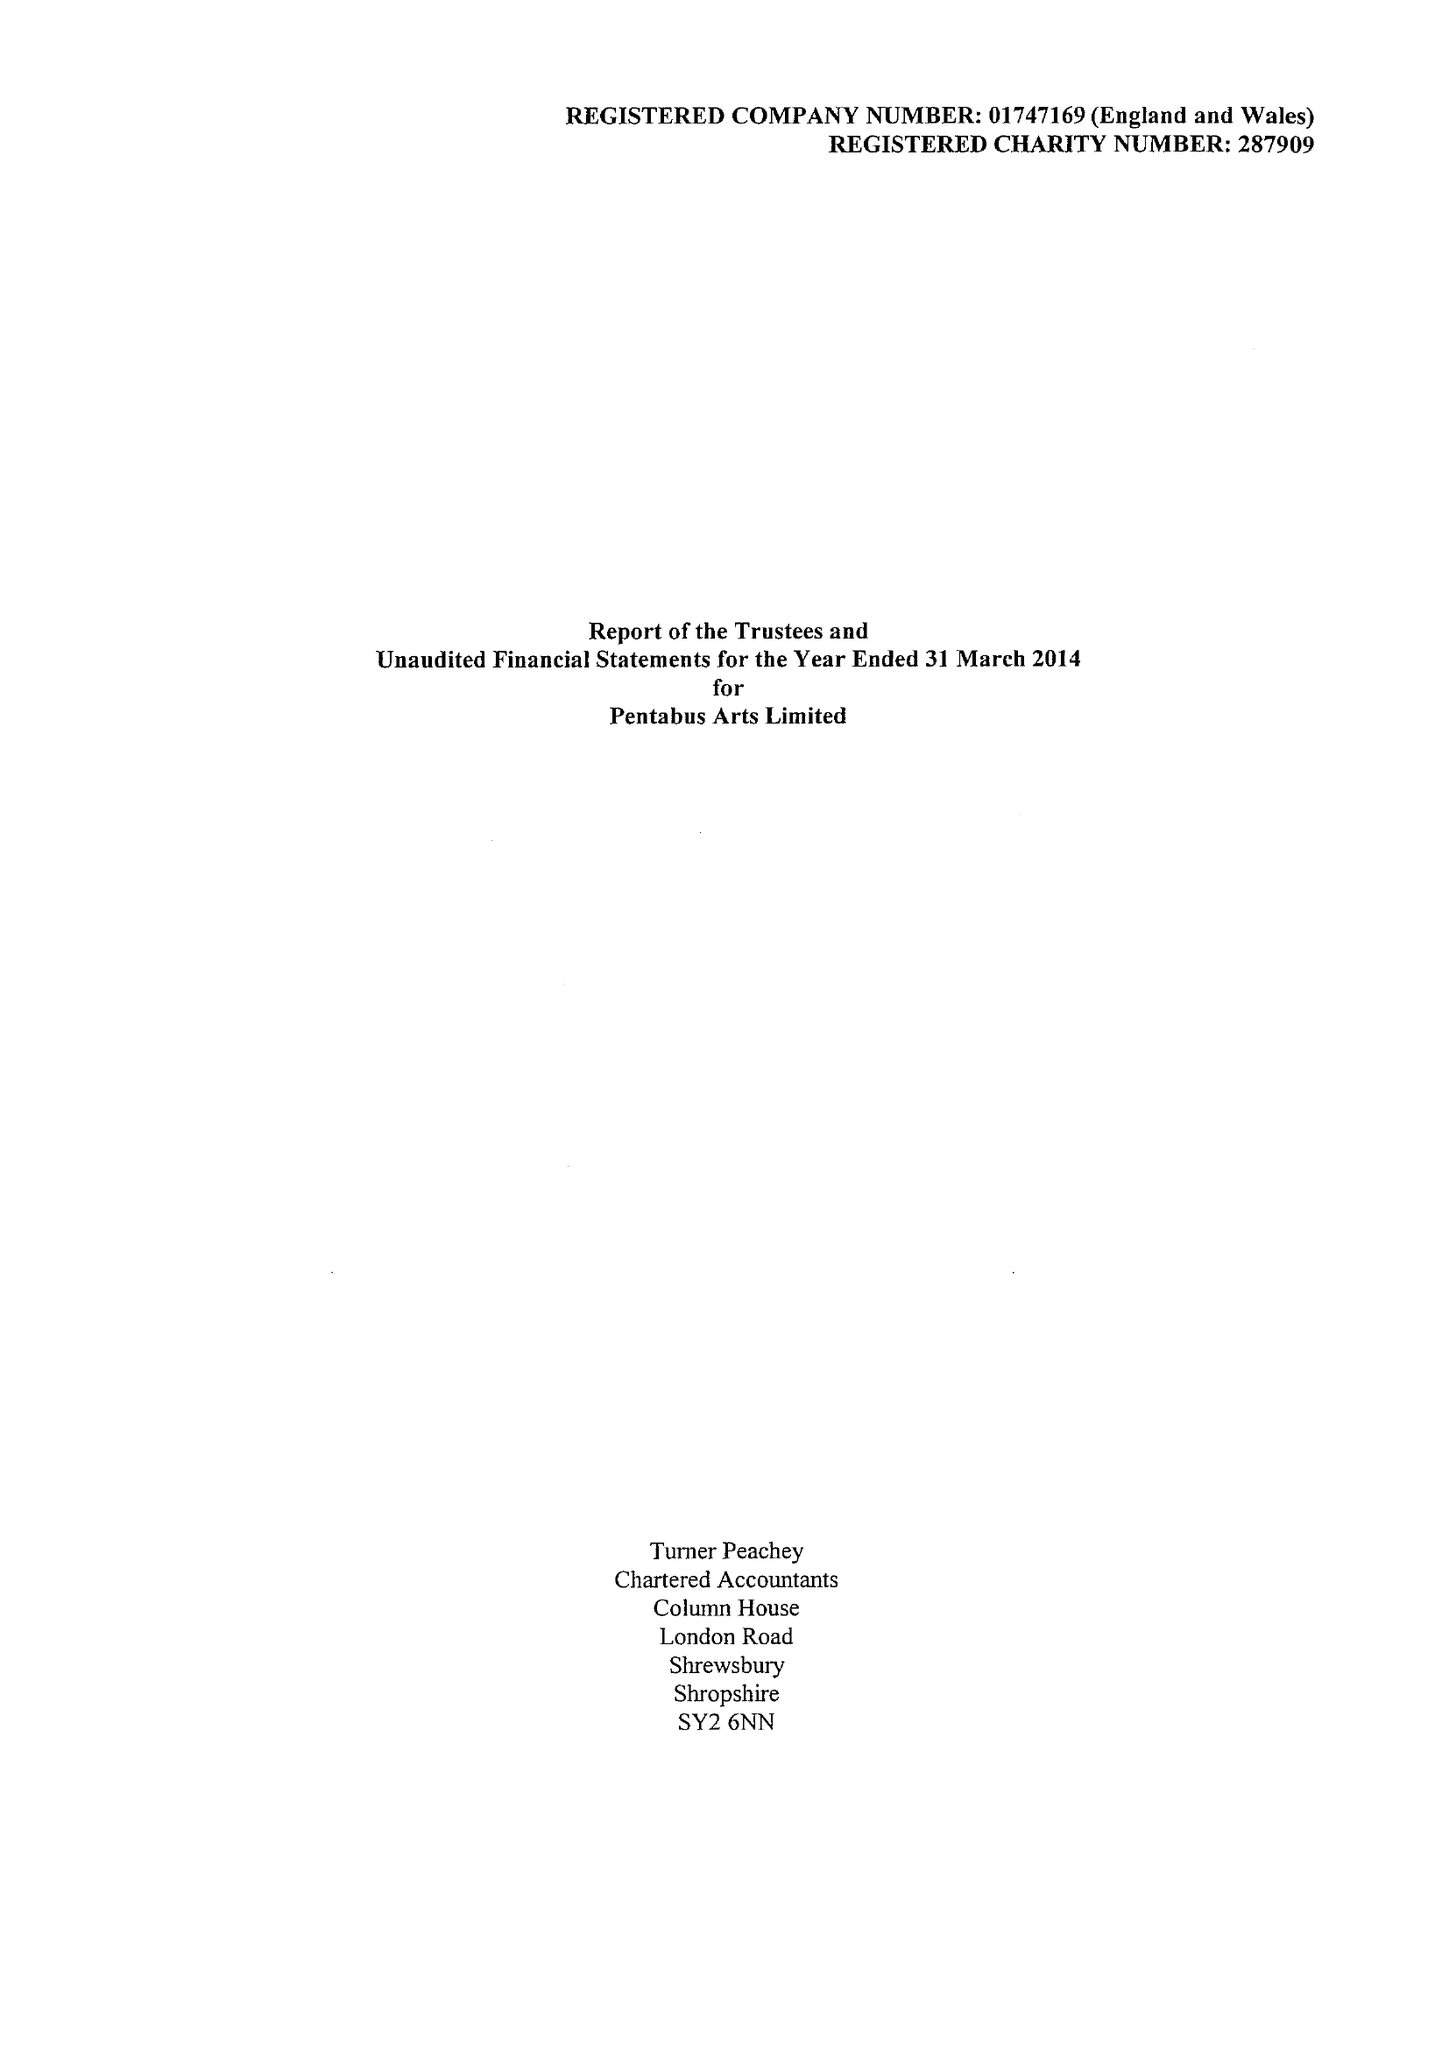What is the value for the charity_number?
Answer the question using a single word or phrase. 287909 